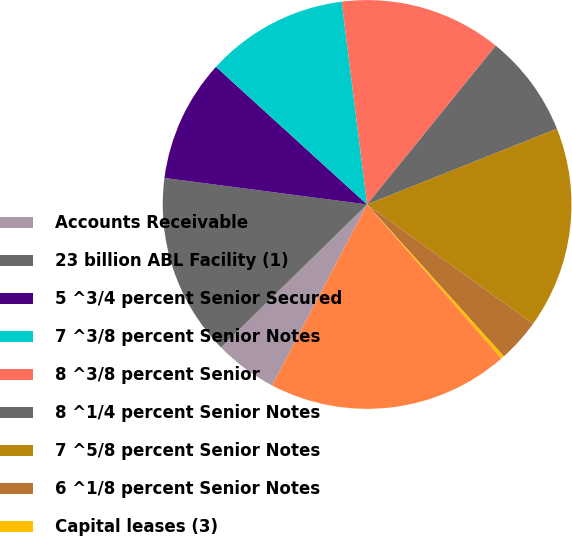Convert chart to OTSL. <chart><loc_0><loc_0><loc_500><loc_500><pie_chart><fcel>Accounts Receivable<fcel>23 billion ABL Facility (1)<fcel>5 ^3/4 percent Senior Secured<fcel>7 ^3/8 percent Senior Notes<fcel>8 ^3/8 percent Senior<fcel>8 ^1/4 percent Senior Notes<fcel>7 ^5/8 percent Senior Notes<fcel>6 ^1/8 percent Senior Notes<fcel>Capital leases (3)<fcel>Total URNA and subsidiaries<nl><fcel>4.98%<fcel>14.4%<fcel>9.69%<fcel>11.26%<fcel>12.83%<fcel>8.12%<fcel>15.97%<fcel>3.41%<fcel>0.27%<fcel>19.1%<nl></chart> 